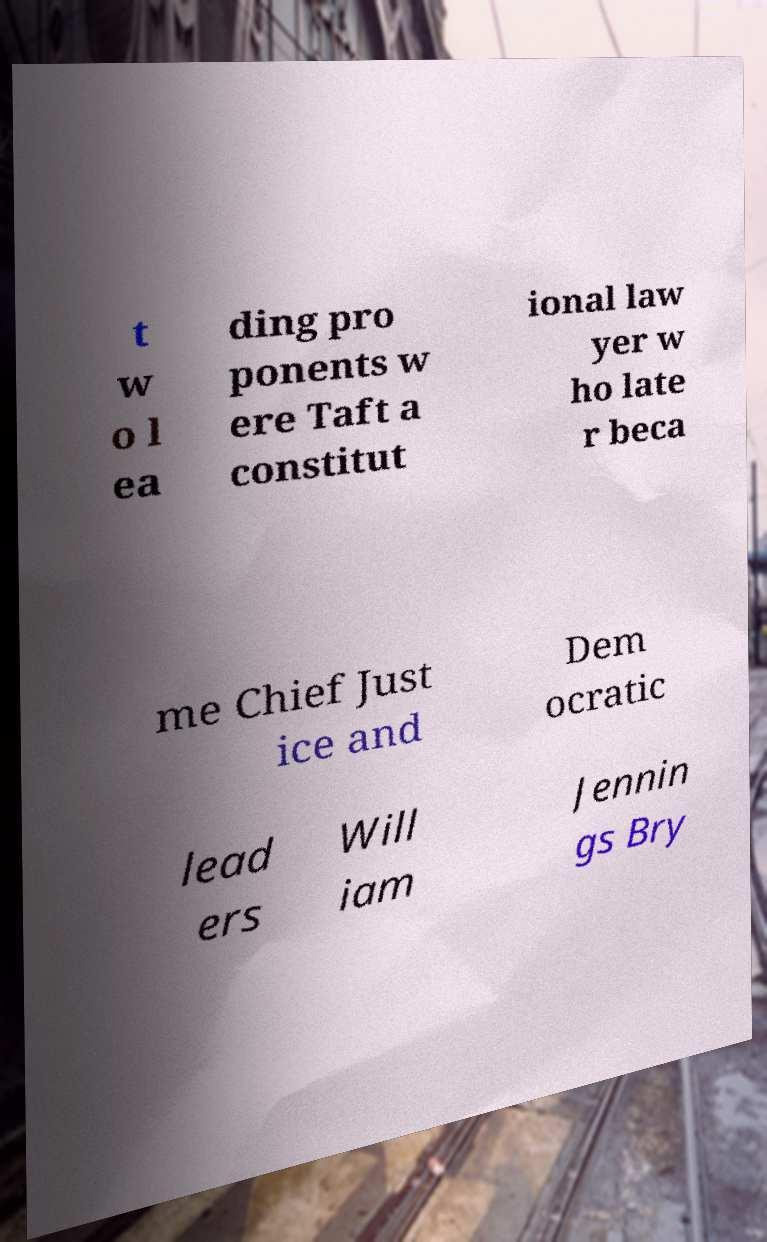There's text embedded in this image that I need extracted. Can you transcribe it verbatim? t w o l ea ding pro ponents w ere Taft a constitut ional law yer w ho late r beca me Chief Just ice and Dem ocratic lead ers Will iam Jennin gs Bry 